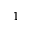Convert formula to latex. <formula><loc_0><loc_0><loc_500><loc_500>1</formula> 